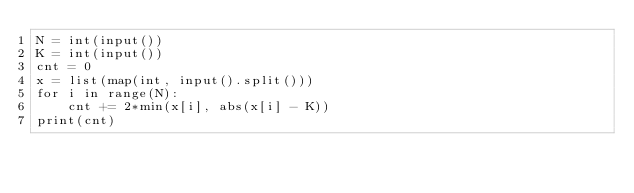Convert code to text. <code><loc_0><loc_0><loc_500><loc_500><_Python_>N = int(input())
K = int(input())
cnt = 0
x = list(map(int, input().split()))
for i in range(N):
    cnt += 2*min(x[i], abs(x[i] - K))
print(cnt)</code> 